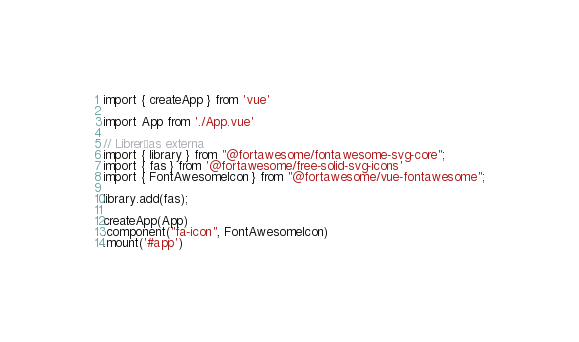Convert code to text. <code><loc_0><loc_0><loc_500><loc_500><_JavaScript_>import { createApp } from 'vue'

import App from './App.vue'

// Librerías externa
import { library } from "@fortawesome/fontawesome-svg-core";
import { fas } from '@fortawesome/free-solid-svg-icons'
import { FontAwesomeIcon } from "@fortawesome/vue-fontawesome";

library.add(fas);

createApp(App)
.component("fa-icon", FontAwesomeIcon)
.mount('#app')
</code> 